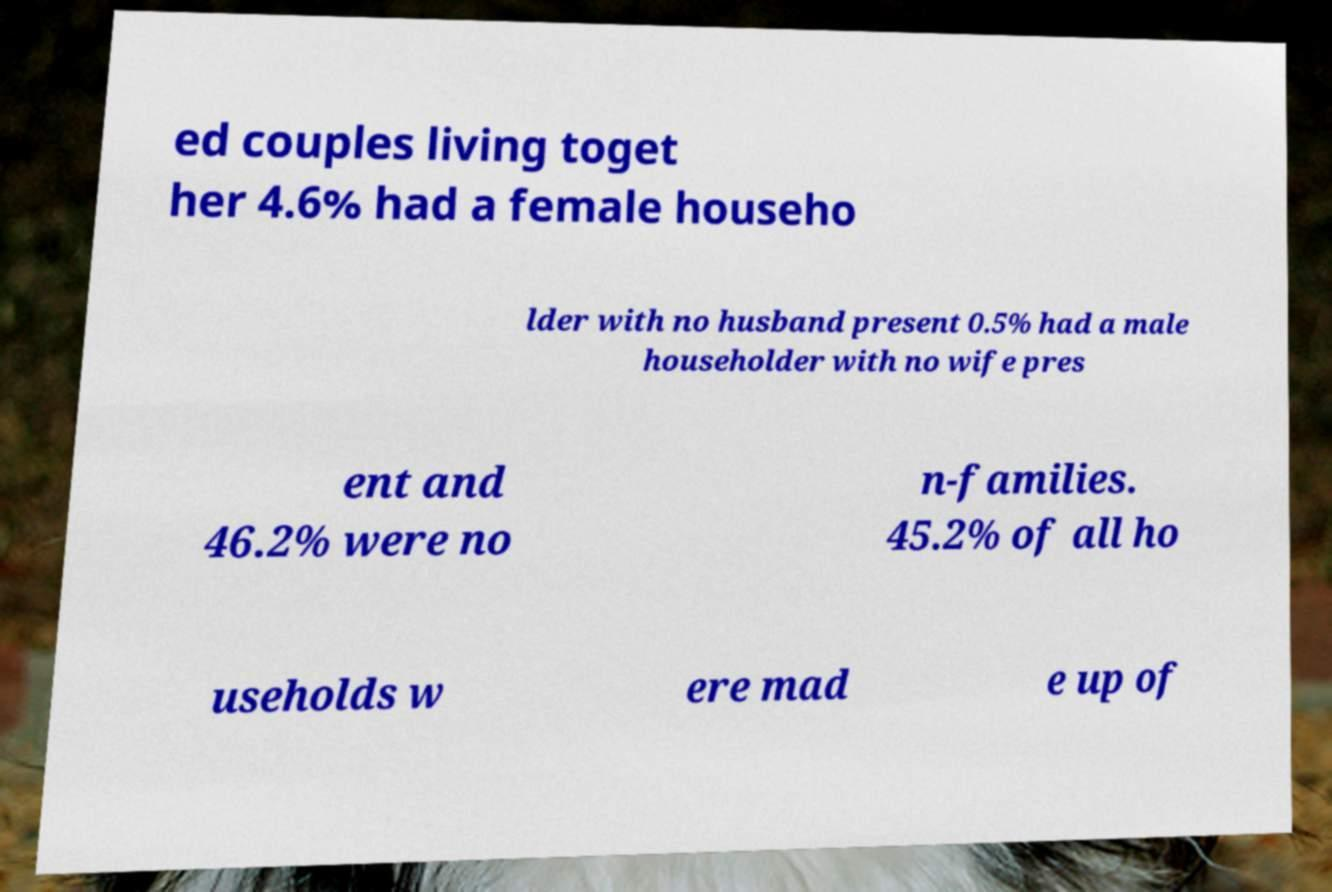Can you accurately transcribe the text from the provided image for me? ed couples living toget her 4.6% had a female househo lder with no husband present 0.5% had a male householder with no wife pres ent and 46.2% were no n-families. 45.2% of all ho useholds w ere mad e up of 